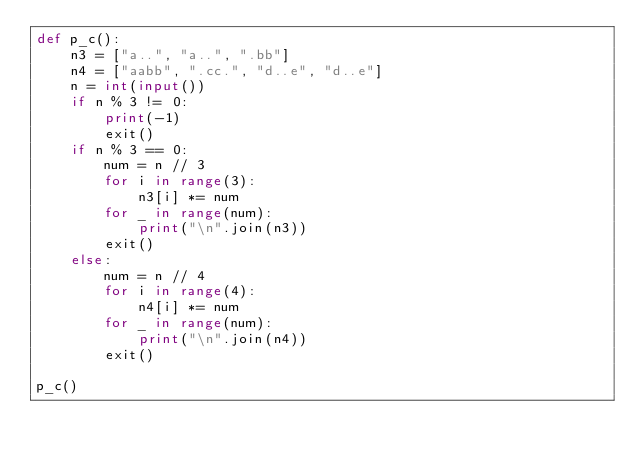Convert code to text. <code><loc_0><loc_0><loc_500><loc_500><_Python_>def p_c():
    n3 = ["a..", "a..", ".bb"]
    n4 = ["aabb", ".cc.", "d..e", "d..e"]
    n = int(input())
    if n % 3 != 0:
        print(-1)
        exit()
    if n % 3 == 0:
        num = n // 3
        for i in range(3):
            n3[i] *= num
        for _ in range(num):
            print("\n".join(n3))
        exit()
    else:
        num = n // 4
        for i in range(4):
            n4[i] *= num
        for _ in range(num):
            print("\n".join(n4))
        exit()
        
p_c()</code> 